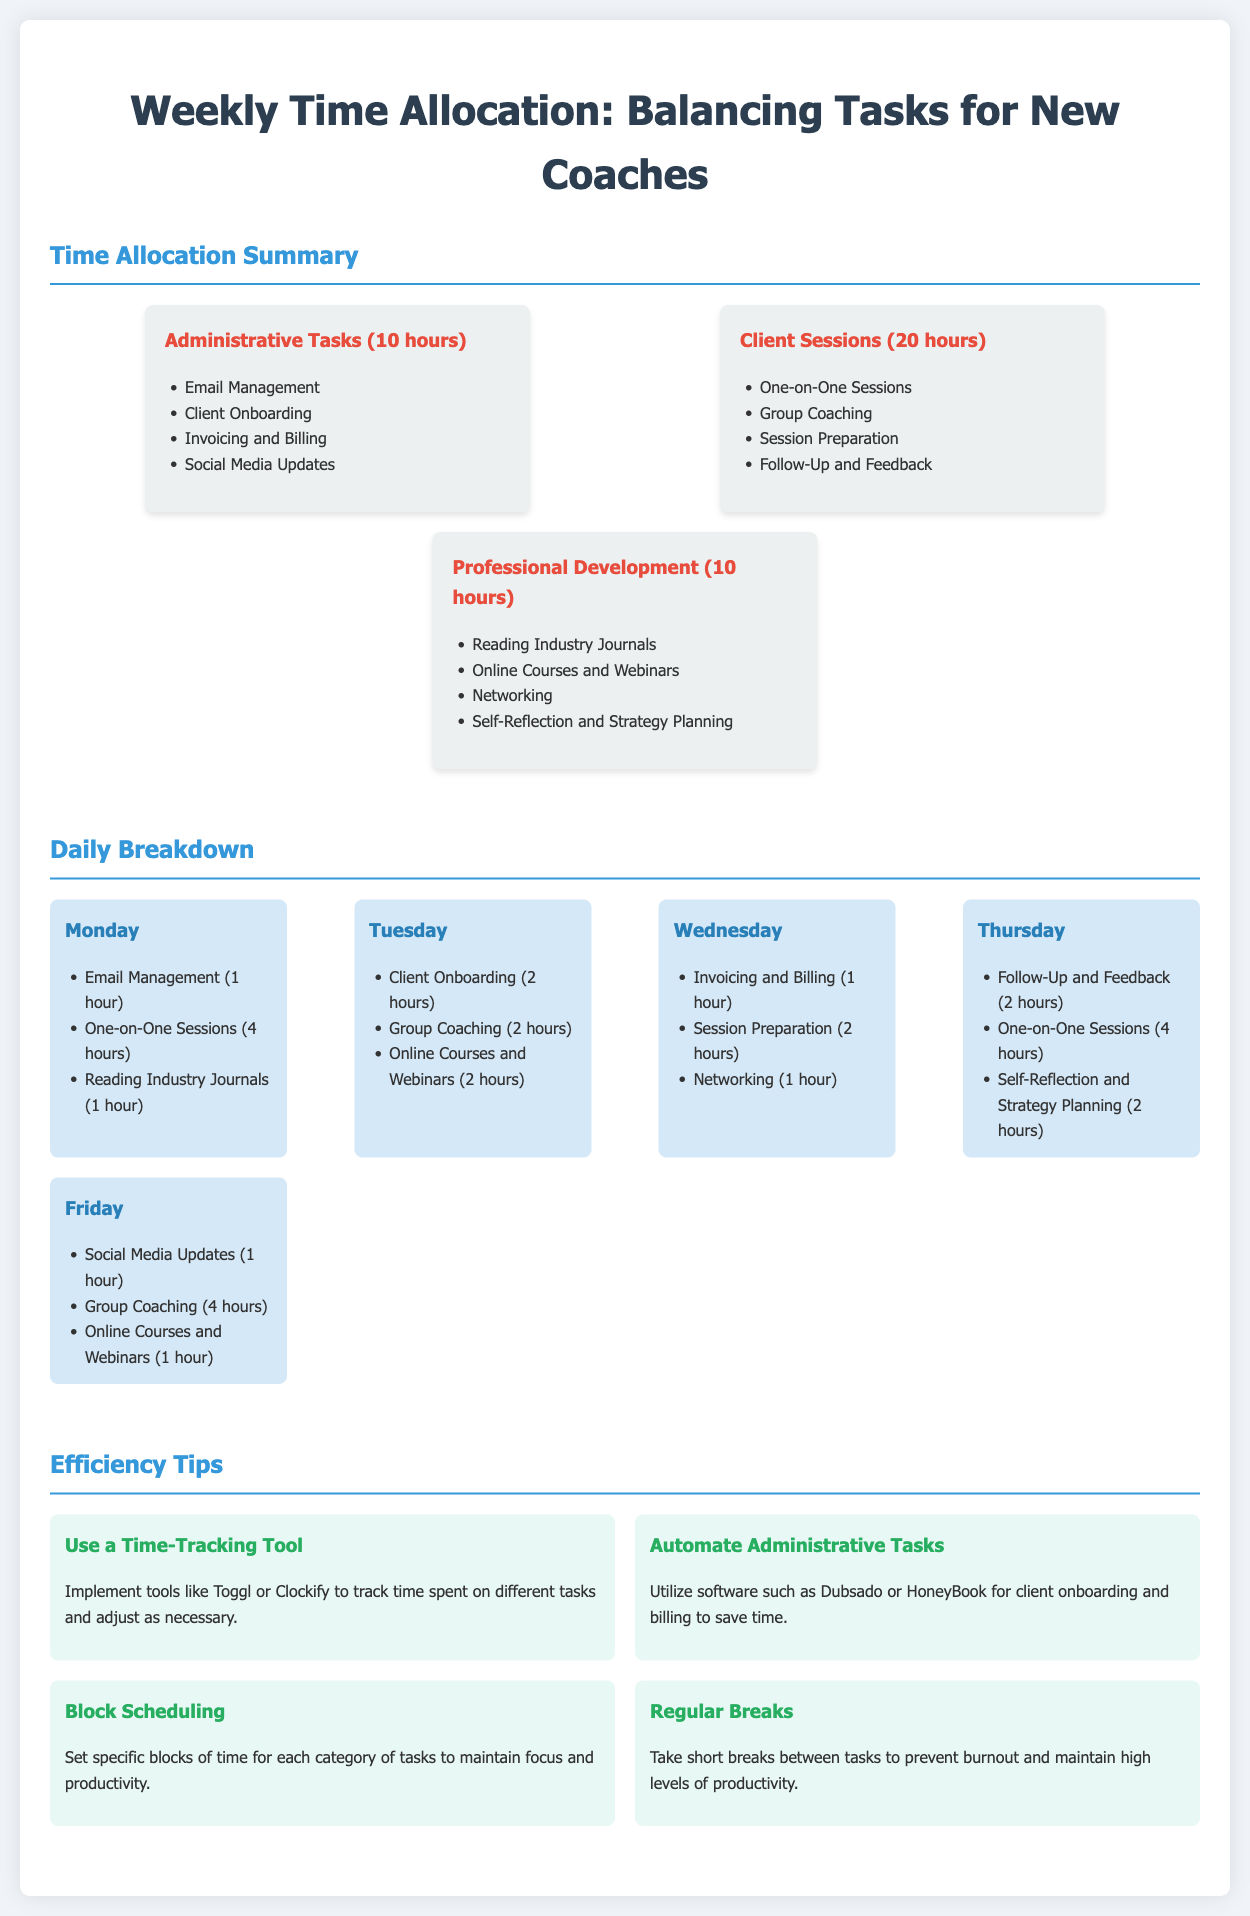What is the total time allocated for Administrative Tasks? The total time allocated for Administrative Tasks is clearly stated as 10 hours in the document.
Answer: 10 hours How many hours are dedicated to Client Sessions? The document specifies that Client Sessions have a dedicated time of 20 hours.
Answer: 20 hours What is one of the activities included under Professional Development? The document lists various activities under Professional Development, including Reading Industry Journals.
Answer: Reading Industry Journals Which day includes Social Media Updates? The document describes that Social Media Updates are scheduled for Friday.
Answer: Friday What task is performed for 4 hours on Monday? The document states that One-on-One Sessions are scheduled for 4 hours on Monday.
Answer: One-on-One Sessions How many hours are spent on Networking throughout the week? The document indicates that Networking is allocated 1 hour on Wednesday, making it 1 hour in total.
Answer: 1 hour What efficiency tip suggests using software for client-related tasks? The document provides a tip about utilizing software such as Dubsado or HoneyBook for automating administrative tasks.
Answer: Automate Administrative Tasks What is the purpose of the Efficiency Tips section? The purpose is to provide suggestions for improving productivity and managing time effectively.
Answer: Improving productivity Which category of tasks has the least allocated time? The document reveals that Administrative Tasks and Professional Development each have the least allocated time at 10 hours.
Answer: Administrative Tasks and Professional Development 